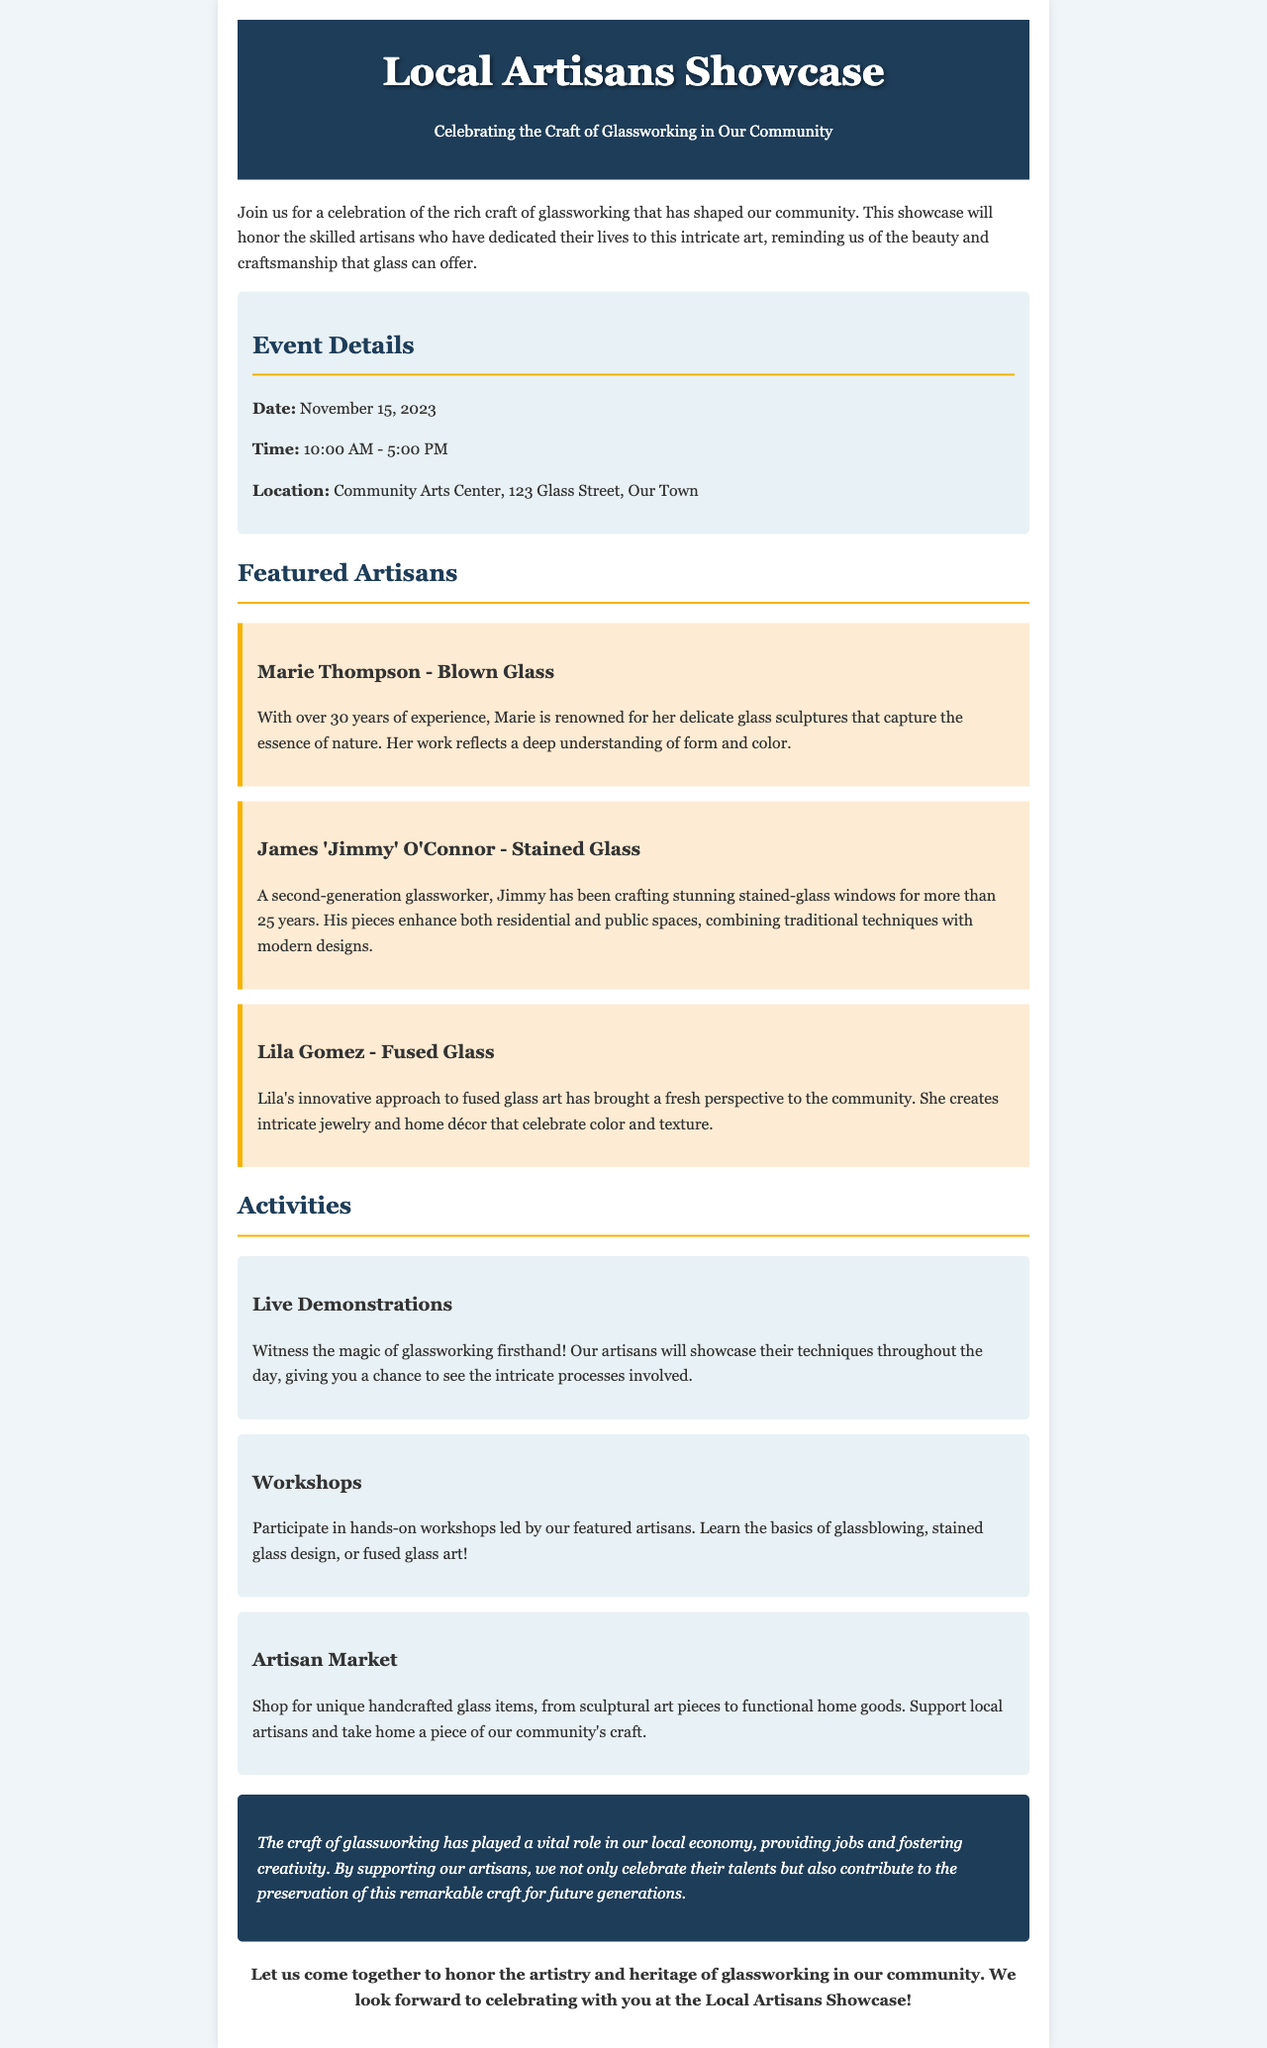What is the date of the event? The date of the event is specified clearly in the document, which states it is on November 15, 2023.
Answer: November 15, 2023 Who is the artisan known for blown glass? The document lists Marie Thompson as the artisan who specializes in blown glass with over 30 years of experience.
Answer: Marie Thompson What time does the event start? The event details section explicitly mentions the start time, which is 10:00 AM.
Answer: 10:00 AM What type of glass art does Lila Gomez create? Lila Gomez is mentioned in the document as a creator of fused glass art, specifically jewelry and home décor.
Answer: Fused glass How long has James 'Jimmy' O'Connor been crafting stained glass? The document indicates Jimmy has been crafting stained glass for over 25 years.
Answer: 25 years What activity allows attendees to see how glassworking is done? The document specifies live demonstrations as an activity where attendees can witness glassworking techniques.
Answer: Live Demonstrations Where is the Local Artisans Showcase being held? The location is provided in the event details, stating that it will be at the Community Arts Center, 123 Glass Street, Our Town.
Answer: Community Arts Center, 123 Glass Street, Our Town What is the purpose of the Artisan Market? The document describes the Artisan Market as a space to shop for unique handcrafted glass items and support local artisans.
Answer: Support local artisans What impact does glassworking have on the local economy? The document mentions that glassworking plays a vital role in providing jobs and fostering creativity in the local economy.
Answer: Providing jobs and fostering creativity 